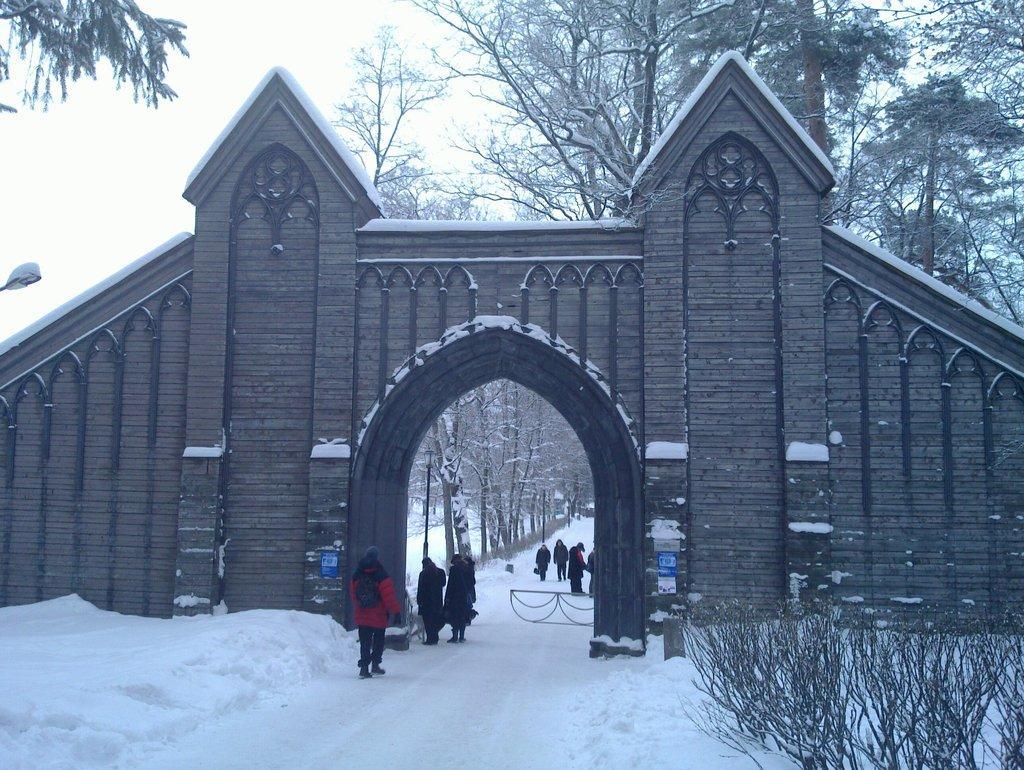In one or two sentences, can you explain what this image depicts? In this picture we can see an arch, wall, snow, trees, street lights and some people on the road and in the background we can see the sky. 